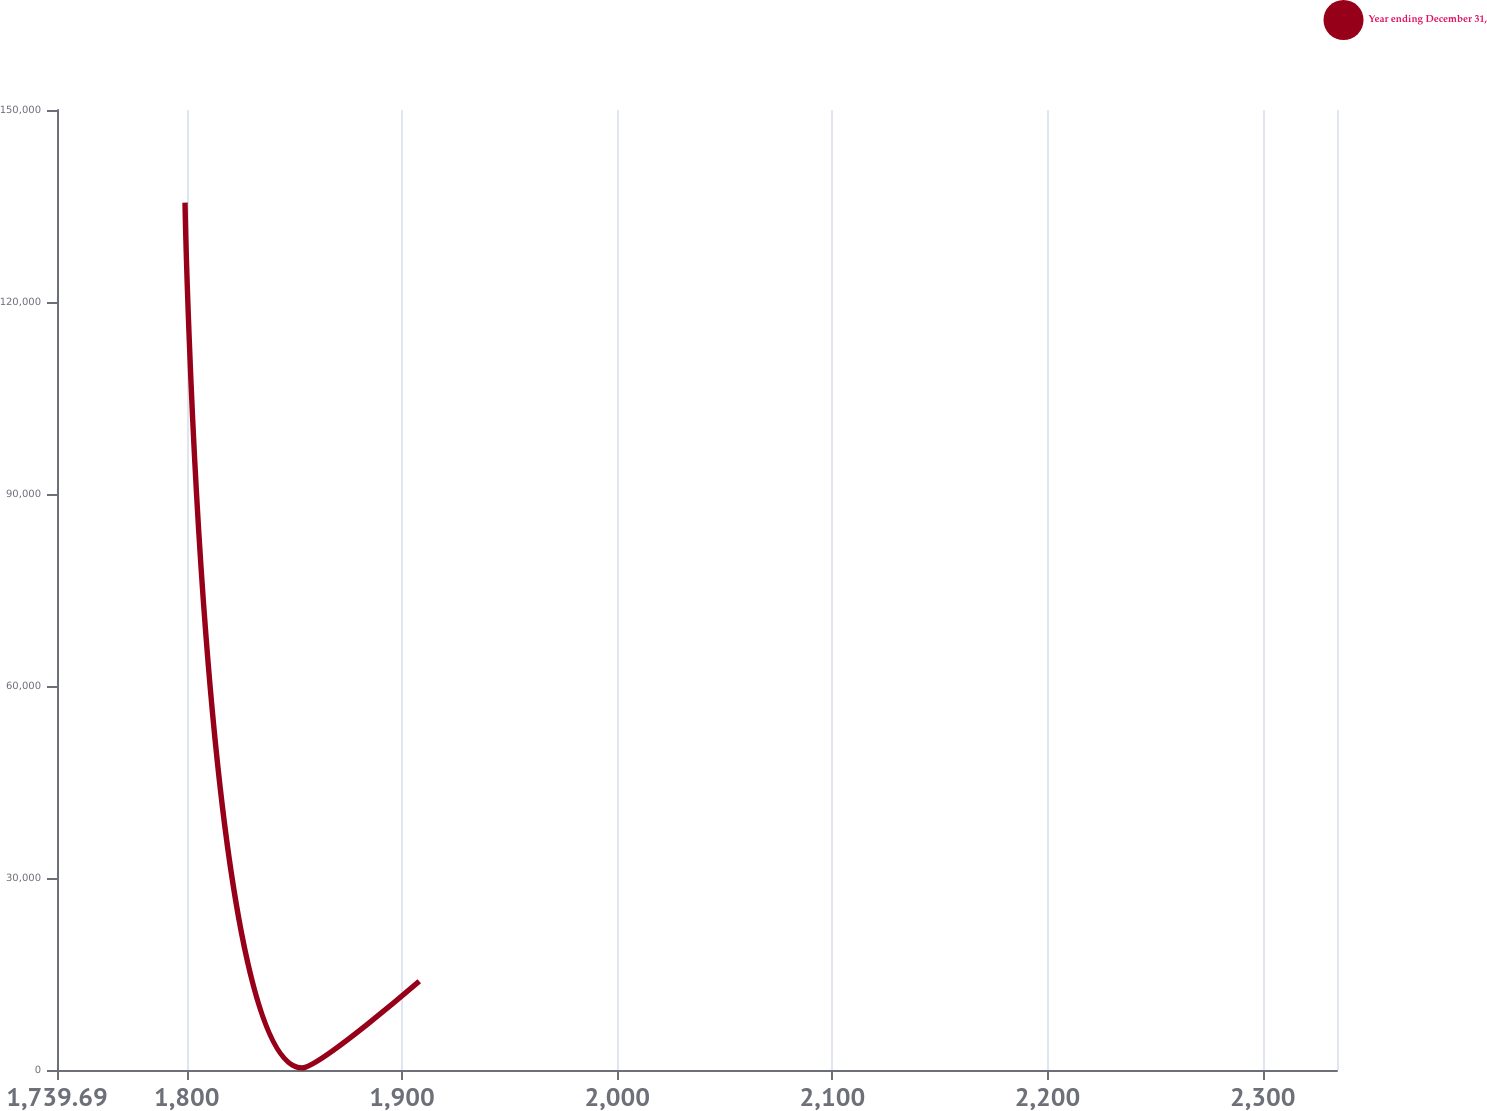Convert chart. <chart><loc_0><loc_0><loc_500><loc_500><line_chart><ecel><fcel>Year ending December 31,<nl><fcel>1799.17<fcel>135529<nl><fcel>1853.6<fcel>337.05<nl><fcel>1908.03<fcel>13856.2<nl><fcel>2339.54<fcel>27375.4<nl><fcel>2393.97<fcel>40894.6<nl></chart> 